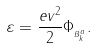Convert formula to latex. <formula><loc_0><loc_0><loc_500><loc_500>\varepsilon = \frac { e v ^ { 2 } } { 2 } \Phi _ { _ { B _ { k } ^ { a } } } .</formula> 